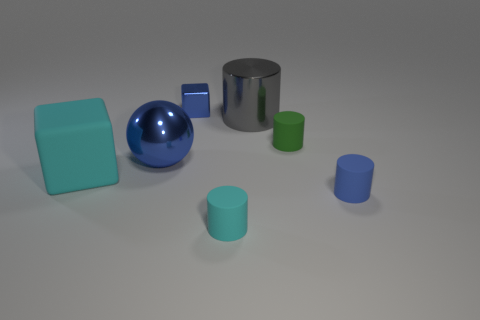There is a cyan block that is the same size as the metallic ball; what is it made of?
Your response must be concise. Rubber. What number of other things are there of the same material as the cyan cylinder
Ensure brevity in your answer.  3. There is a cube that is right of the metallic sphere; is its color the same as the rubber cylinder that is left of the green object?
Ensure brevity in your answer.  No. There is a small thing that is behind the matte cylinder behind the large ball; what is its shape?
Offer a terse response. Cube. What number of other objects are there of the same color as the sphere?
Provide a succinct answer. 2. Do the large object in front of the shiny sphere and the cylinder that is right of the green cylinder have the same material?
Provide a succinct answer. Yes. How big is the cube behind the big cyan cube?
Your response must be concise. Small. There is a big gray object that is the same shape as the blue rubber thing; what is its material?
Offer a terse response. Metal. There is a rubber object on the left side of the tiny shiny block; what shape is it?
Give a very brief answer. Cube. What number of tiny cyan things are the same shape as the small green rubber object?
Your response must be concise. 1. 